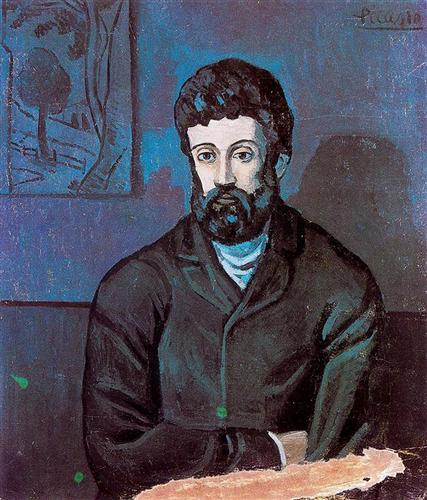Imagine this man had a hidden treasure chest nearby. What could be inside? Hidden within the treasure chest might be a myriad of objects that narrate the man’s life story – aged letters and diaries detailing his thoughts and adventures, a collection of small mementos such as seashells or old coins that bring memories from far-off places, and perhaps an old watch or piece of jewelry passed down through generations. The chest could also contain sketches and unfinished artworks, revealing a creative spirit and a life filled with unspoken dreams.  Who might the man in the portrait be waiting for? In the portrait, the man might be waiting for a long-lost friend or a loved one. His expression suggests a mix of hope and resignation, as if he has been waiting for quite some time. The person he awaits is likely someone of great importance to him, perhaps a figure from his past who holds sentimental value or a loved one whose return he eagerly anticipates, but isn't certain about when or if they will arrive. 